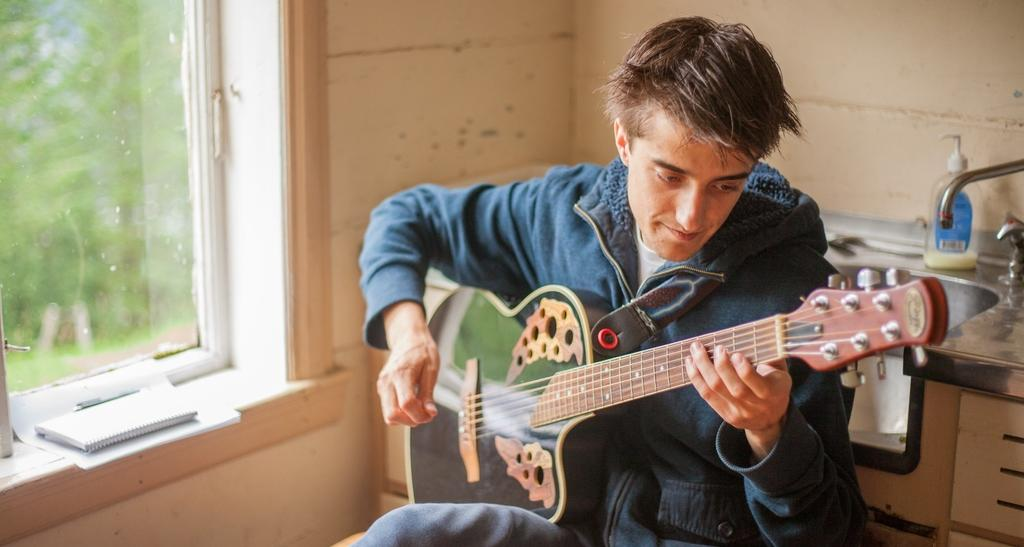What type of structure is visible in the image? There is a wall in the image. What feature is present in the wall? There is a window in the image. Who is present in the image? There is a man in the image. What is the man holding in the image? The man is holding a guitar. What channel is the man watching on the wall in the image? There is no television or channel present in the image; it only features a wall, a window, and a man holding a guitar. 